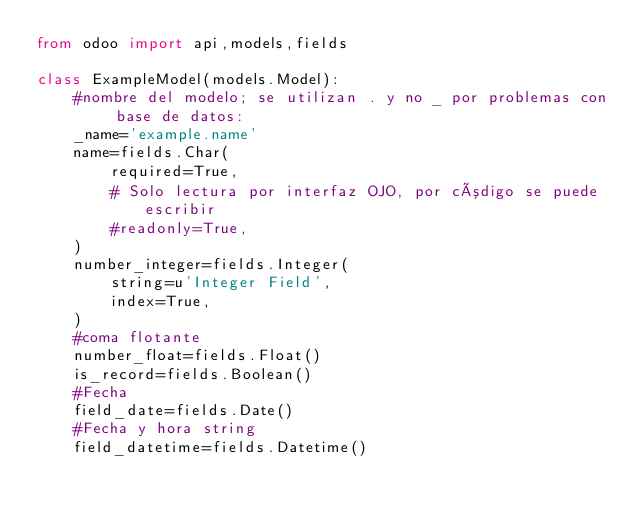<code> <loc_0><loc_0><loc_500><loc_500><_Python_>from odoo import api,models,fields

class ExampleModel(models.Model):
    #nombre del modelo; se utilizan . y no _ por problemas con base de datos:
    _name='example.name'
    name=fields.Char(
        required=True,
        # Solo lectura por interfaz OJO, por código se puede escribir
        #readonly=True,
    )
    number_integer=fields.Integer(
        string=u'Integer Field',
        index=True,
    )
    #coma flotante
    number_float=fields.Float()
    is_record=fields.Boolean()
    #Fecha
    field_date=fields.Date()
    #Fecha y hora string
    field_datetime=fields.Datetime()



</code> 